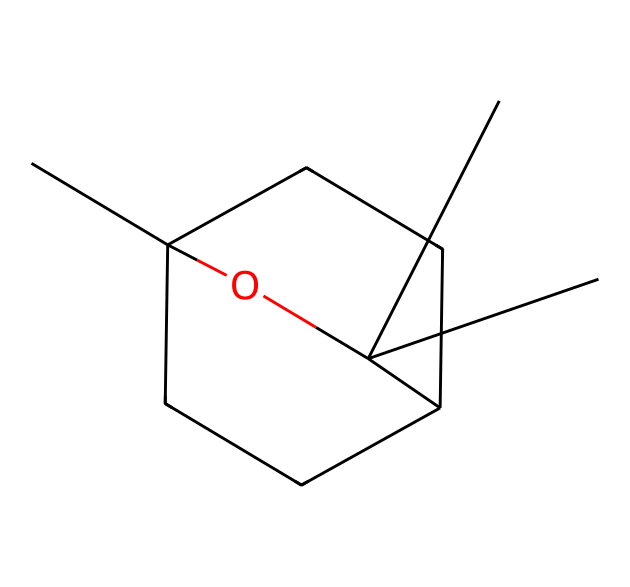What is the molecular formula of eucalyptol? To determine the molecular formula, we can count the number of each type of atom in the SMILES representation. The representation shows a structure with multiple carbon (C) and oxygen (O) atoms. Upon counting, there are 10 carbon atoms and 18 hydrogen atoms, along with 1 oxygen atom. Therefore, the molecular formula is C10H18O.
Answer: C10H18O How many oxygen atoms are present in eucalyptol? In the SMILES representation provided, we can see there is one oxygen atom represented. This is indicated by the "O" in the structure, which corresponds directly to the oxygen present in eucalyptol.
Answer: 1 What type of chemical structure is eucalyptol primarily classified as? Eucalyptol is primarily classified as a monoterpene. This classification is based on its structure, which features a significant number of carbon atoms arranged in a cyclic form typical of terpenes.
Answer: monoterpene How many rings are present in the eucalyptol structure? By analyzing the SMILES representation, we can identify that there are two rings in the structure. The numbers "1" and "2" indicate the starting and ending points of the ring systems in this particular compound.
Answer: 2 Is eucalyptol a saturated or unsaturated compound? Eucalyptol is an unsaturated compound. Observing the structure reveals that there are double bonds present between some of the carbon atoms, which defines its unsaturated characteristics, as saturated compounds contain only single bonds.
Answer: unsaturated What property of eucalyptol contributes to its soothing aroma? The aromatic properties of eucalyptol contribute to its soothing aroma. This compound has a unique structure that allows it to have a fragrant scent, commonly associated with eucalyptus.
Answer: aromatic 